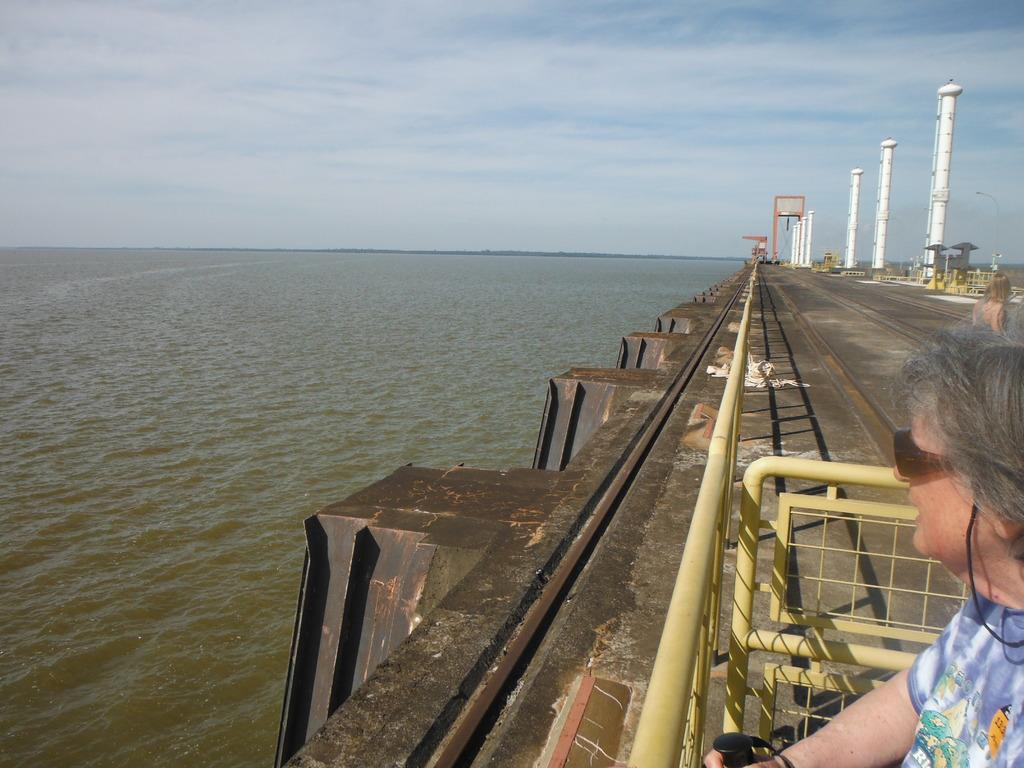What is the main feature in the middle of the image? There is a river in the middle of the image. What can be seen on the right side of the image? There is a woman and a road on the right side of the image. What is visible in the background of the image? The sky is visible in the background of the image. What type of cart is being used by the woman to skate on the river? There is no cart or skating activity present in the image. The woman is not on the river, and there is no indication of any cart or skating equipment. 